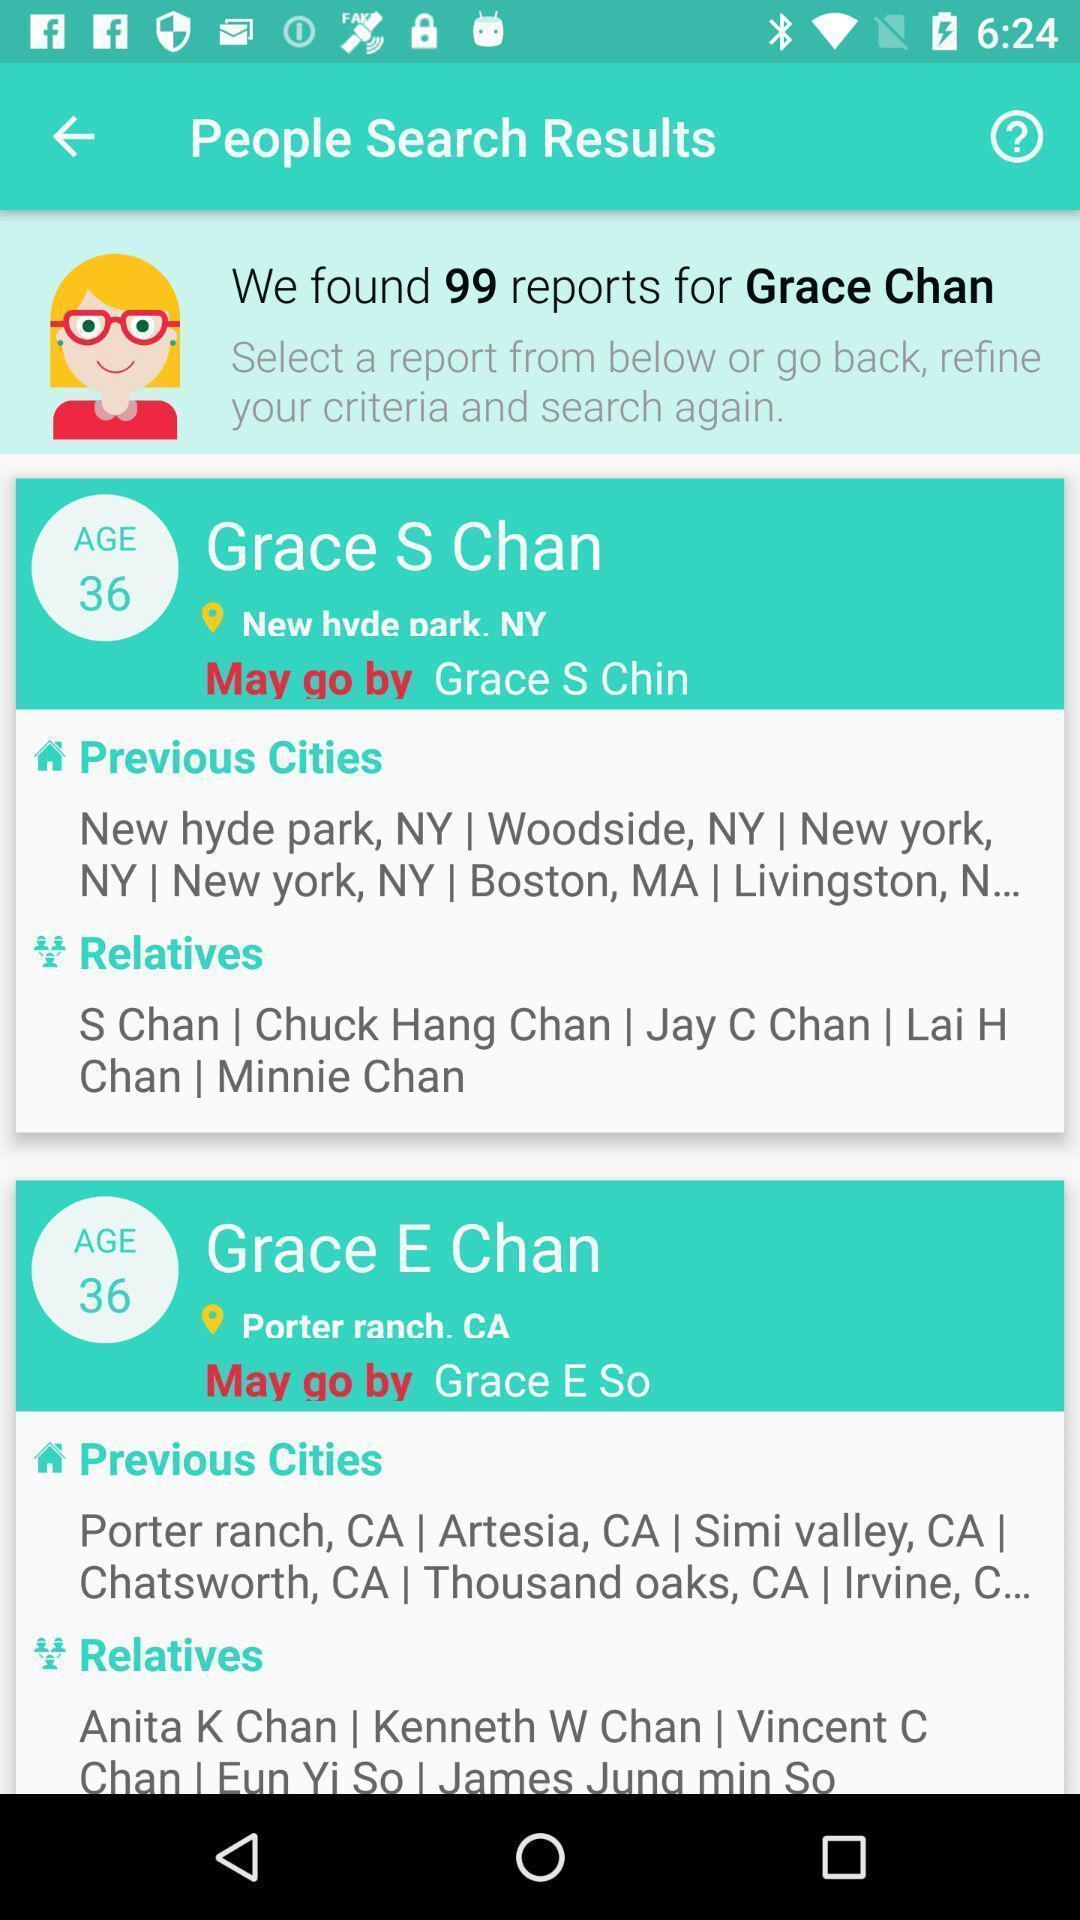Explain what's happening in this screen capture. Screen shows search results page. 